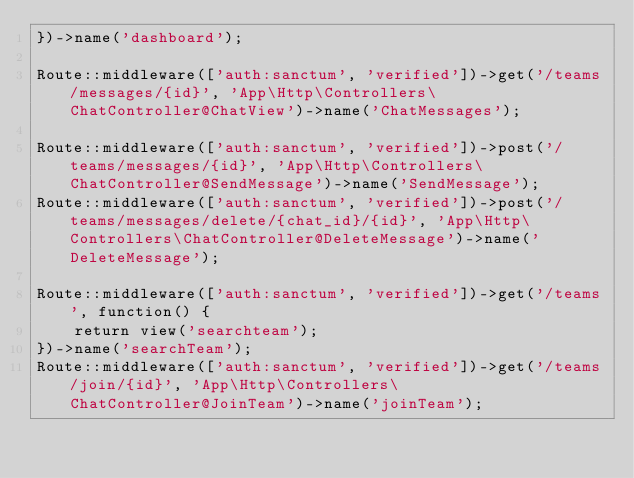Convert code to text. <code><loc_0><loc_0><loc_500><loc_500><_PHP_>})->name('dashboard');

Route::middleware(['auth:sanctum', 'verified'])->get('/teams/messages/{id}', 'App\Http\Controllers\ChatController@ChatView')->name('ChatMessages');

Route::middleware(['auth:sanctum', 'verified'])->post('/teams/messages/{id}', 'App\Http\Controllers\ChatController@SendMessage')->name('SendMessage');
Route::middleware(['auth:sanctum', 'verified'])->post('/teams/messages/delete/{chat_id}/{id}', 'App\Http\Controllers\ChatController@DeleteMessage')->name('DeleteMessage');

Route::middleware(['auth:sanctum', 'verified'])->get('/teams', function() {
    return view('searchteam');
})->name('searchTeam');
Route::middleware(['auth:sanctum', 'verified'])->get('/teams/join/{id}', 'App\Http\Controllers\ChatController@JoinTeam')->name('joinTeam');</code> 